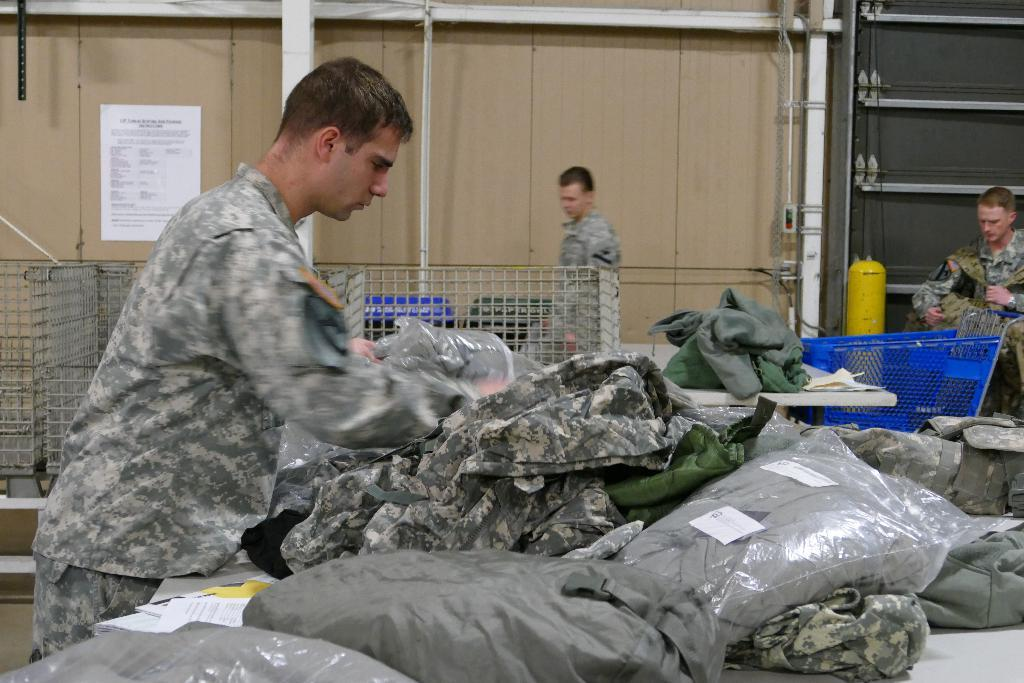Who or what is present in the image? There are people in the image. What can be seen related to clothing or fashion? There are clothes visible in the image. What type of material is used for the wall in the image? There is a wooden wall in the image. What kind of decoration or message is displayed on the wall? There is a poster in the image. Can you describe any other objects or items in the image? There are some unspecified objects in the image. What type of match is being played in the image? There is no match or competition visible in the image; it only shows people, clothes, a wooden wall, a poster, and unspecified objects. 